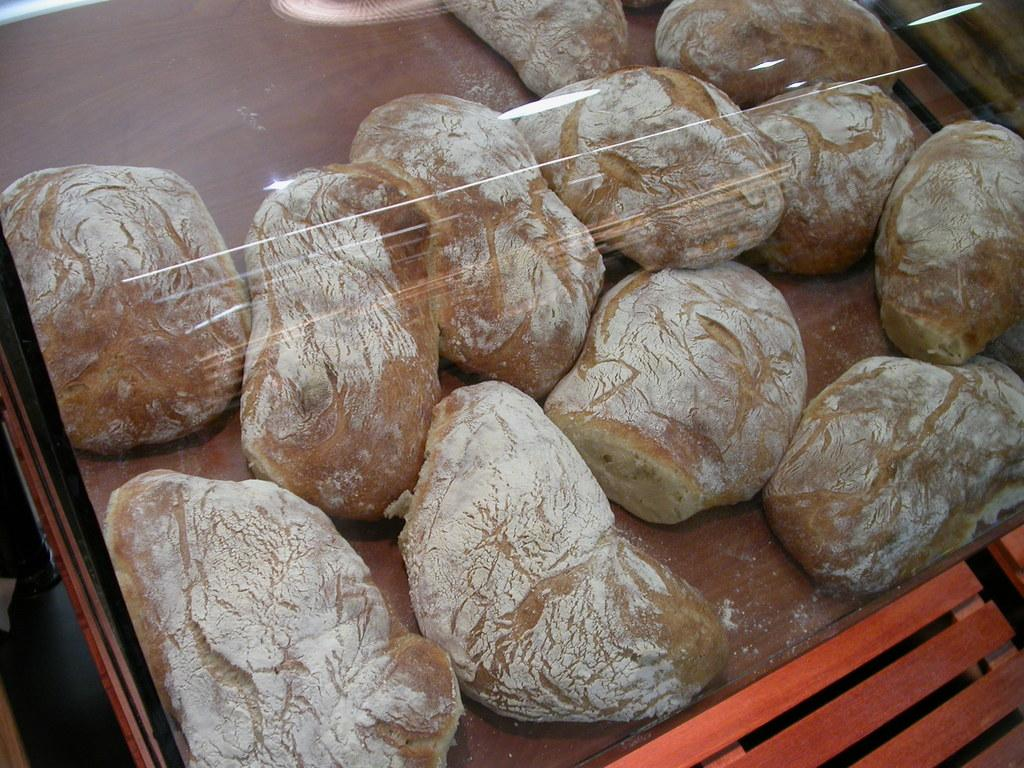What is the main subject of the image? The main subject of the image is food items in the center. Where are the food items located in relation to other objects in the image? The food items are in the center of the image. What other object can be seen in the image? There is a table at the bottom of the image. What rule is being enforced by the passenger in the image? There is no passenger present in the image, and therefore no rule enforcement can be observed. 